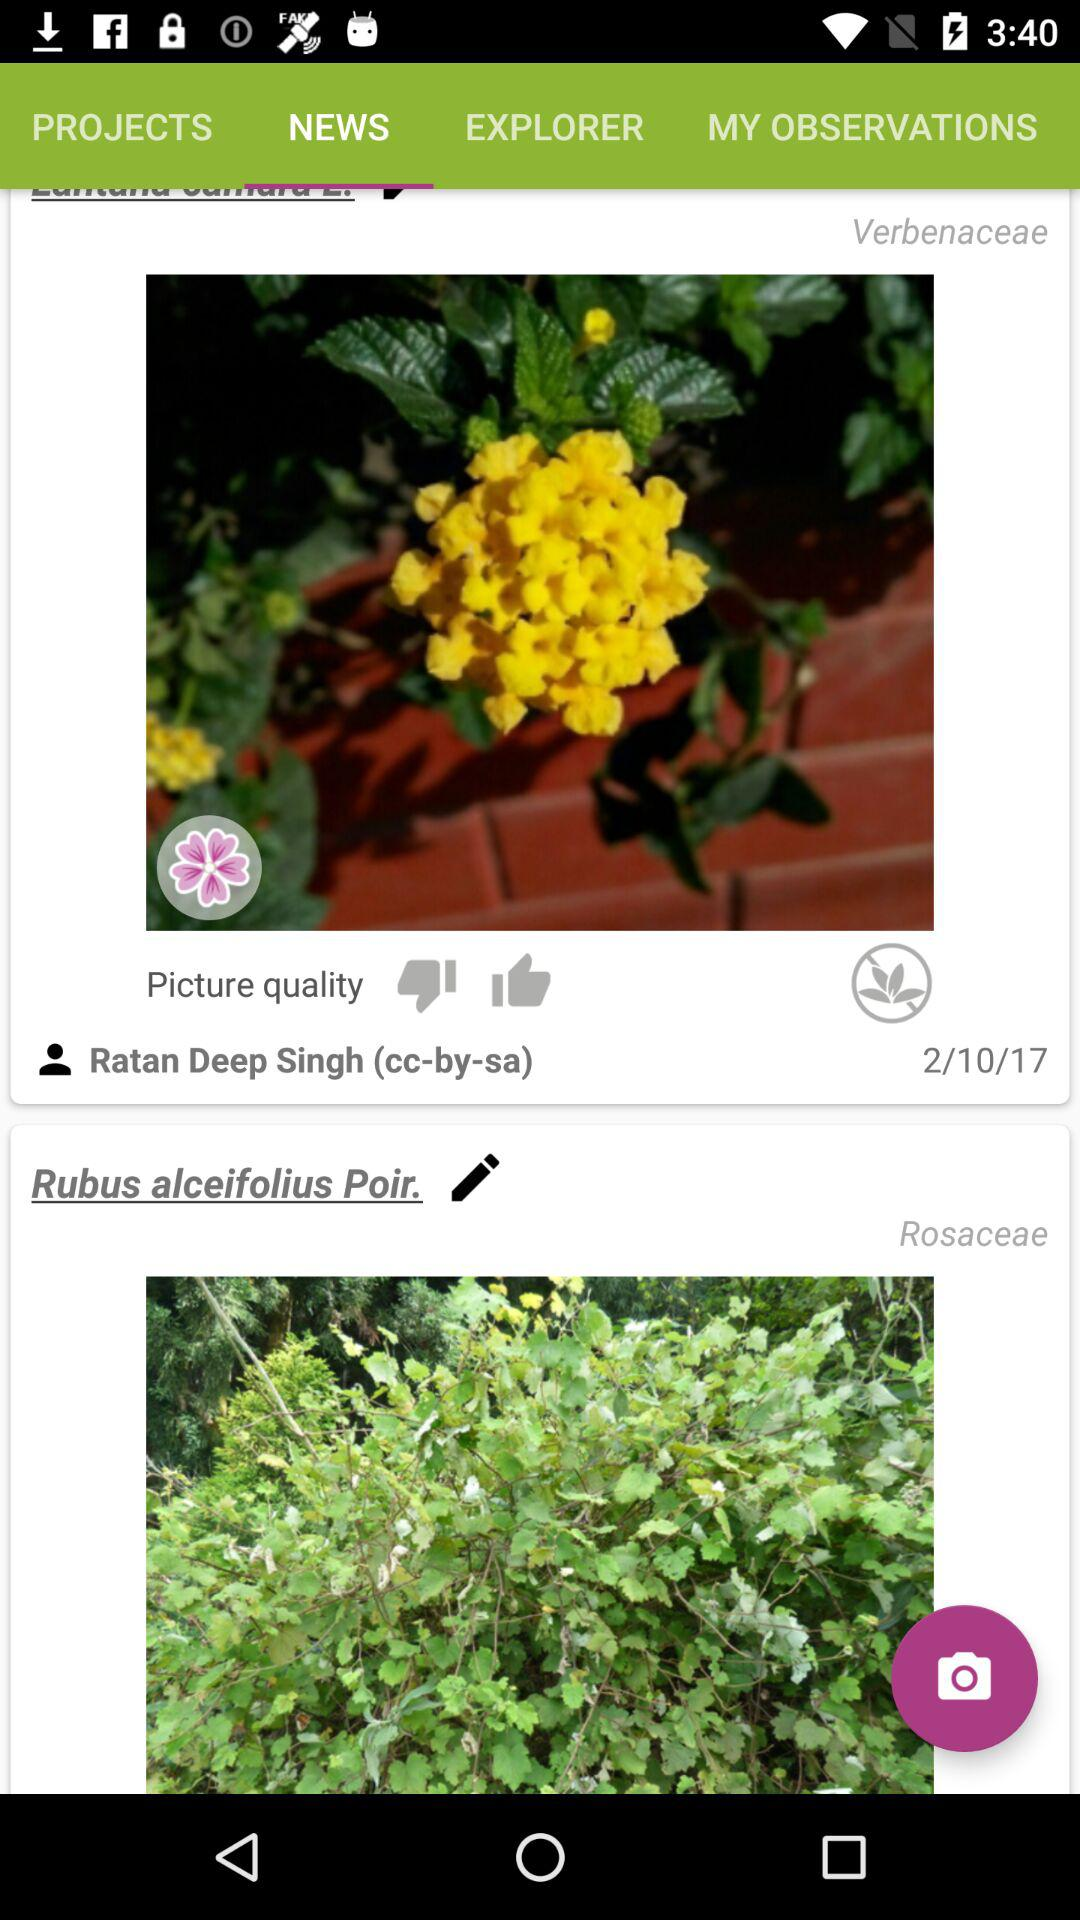Who took the photo of a Verbenaceae? The photo of a Verbenaceae was taken by Ratan Deep Singh. 